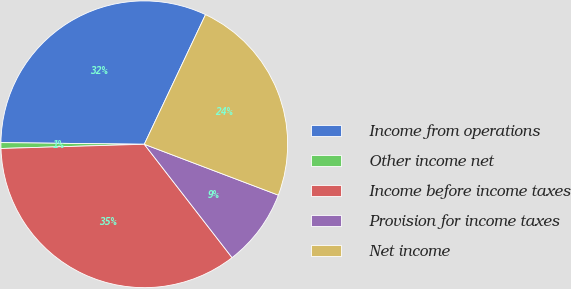Convert chart to OTSL. <chart><loc_0><loc_0><loc_500><loc_500><pie_chart><fcel>Income from operations<fcel>Other income net<fcel>Income before income taxes<fcel>Provision for income taxes<fcel>Net income<nl><fcel>31.84%<fcel>0.65%<fcel>35.02%<fcel>8.74%<fcel>23.75%<nl></chart> 